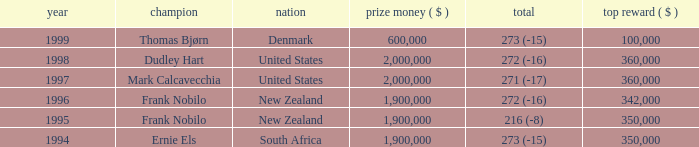What was the total purse in the years after 1996 with a score of 272 (-16) when frank nobilo won? None. 